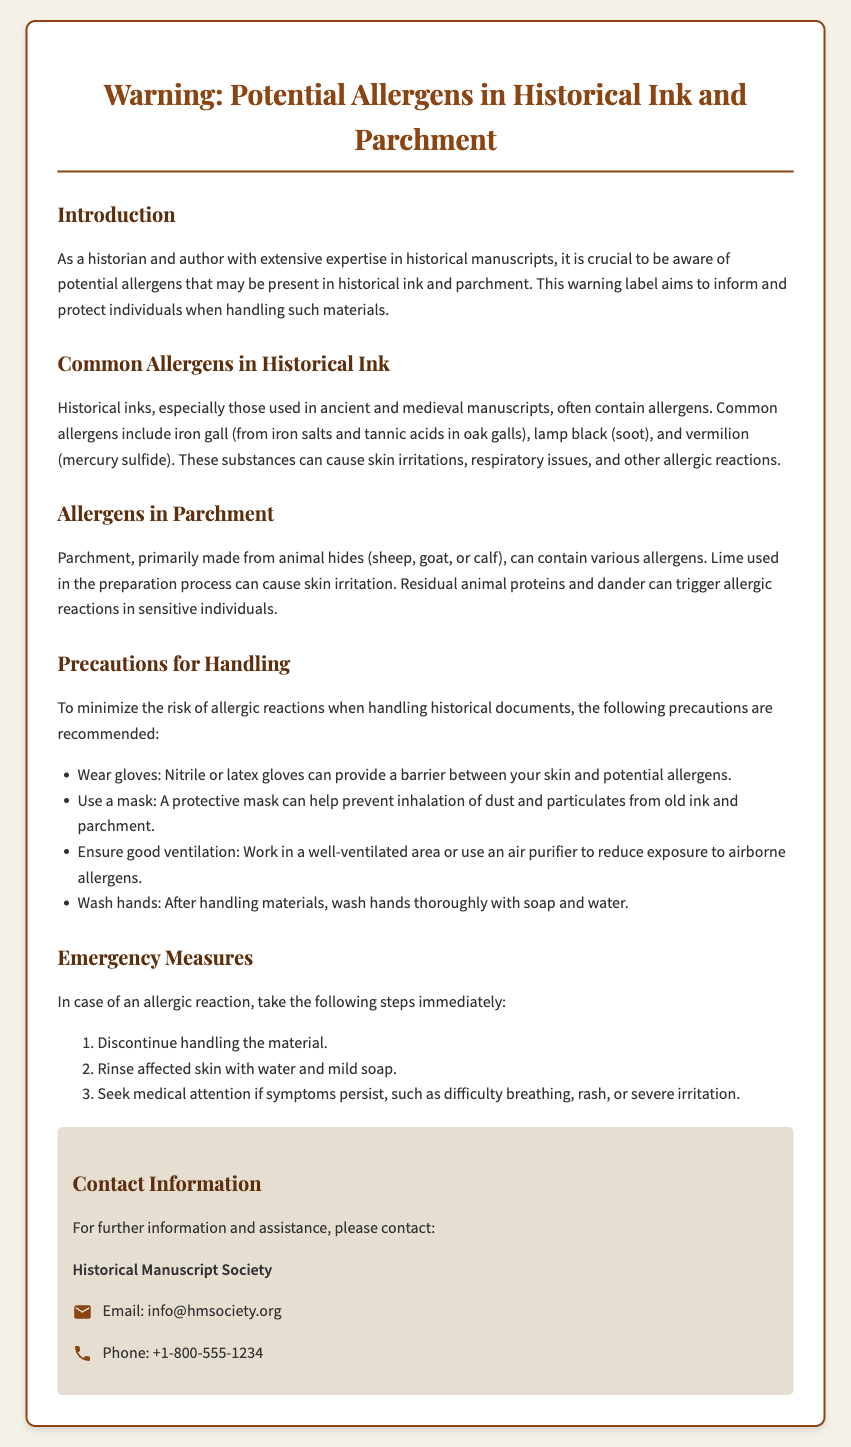What are common allergens in historical ink? Common allergens in historical ink include iron gall, lamp black, and vermilion.
Answer: iron gall, lamp black, and vermilion What should you do in case of an allergic reaction? In case of an allergic reaction, it is recommended to discontinue handling the material, rinse affected skin, and seek medical attention if symptoms persist.
Answer: Discontinue handling the material, rinse affected skin, seek medical attention What type of gloves should be worn? The document suggests wearing nitrile or latex gloves as a precaution.
Answer: nitrile or latex gloves What is the contact email for the Historical Manuscript Society? The contact email provided in the document is info@hmsociety.org.
Answer: info@hmsociety.org What is the main material used to make parchment? Parchment is primarily made from animal hides such as sheep, goat, or calf.
Answer: animal hides What precaution helps prevent inhalation of old ink dust? Using a protective mask is recommended to prevent inhalation of dust and particulates.
Answer: protective mask What is the first step to take if allergic symptoms occur? The first step to take in case of an allergic reaction is to discontinue handling the material.
Answer: Discontinue handling the material What type of area should you work in to minimize allergens? The document recommends working in a well-ventilated area to reduce allergen exposure.
Answer: well-ventilated area 